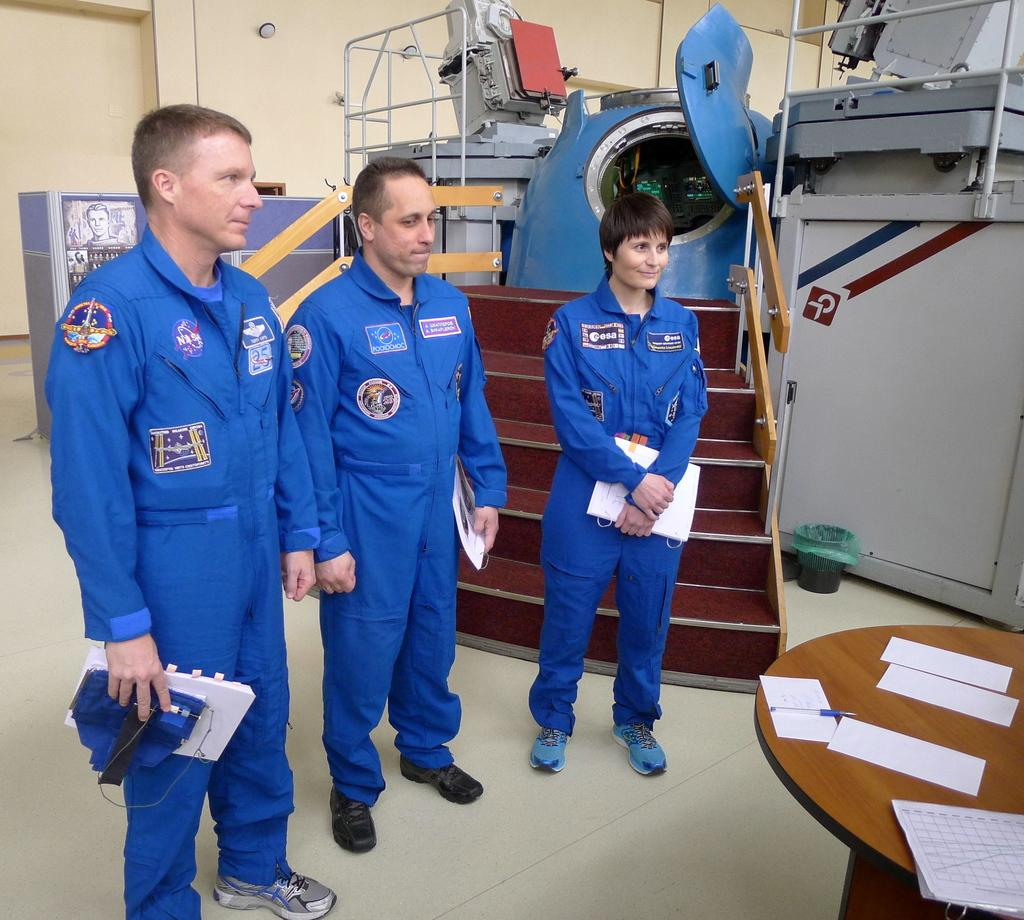What are the people in the image holding in their hands? The people in the image are holding objects in their hands. What architectural feature can be seen in the image? There are stairs in the image. What type of furniture is present in the image? There is a wooden table in the image. What type of material is visible in the image? There are papers in the image. What other objects can be seen in the image? There are other objects present in the image. What type of meal is being prepared on the wooden table in the image? There is no meal being prepared on the wooden table in the image; it is not a kitchen setting. 